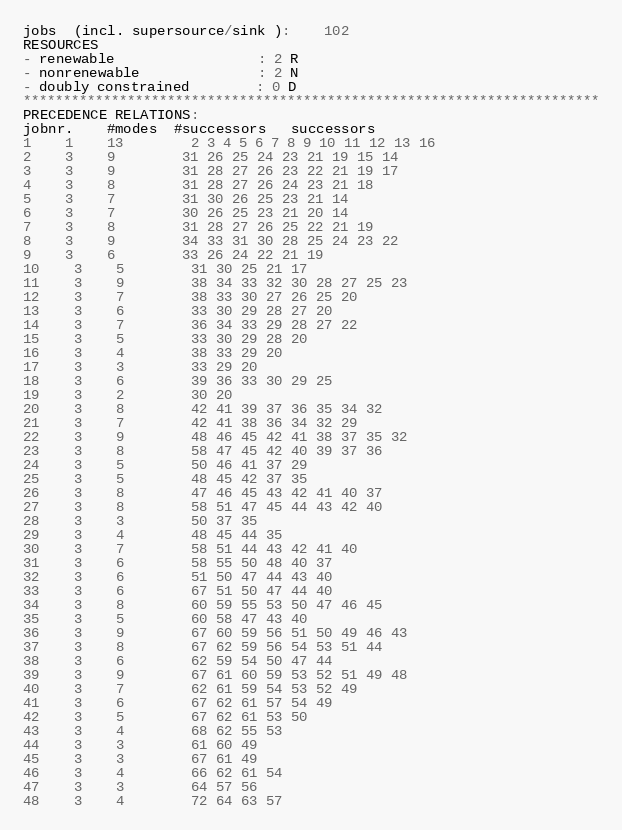<code> <loc_0><loc_0><loc_500><loc_500><_ObjectiveC_>jobs  (incl. supersource/sink ):	102
RESOURCES
- renewable                 : 2 R
- nonrenewable              : 2 N
- doubly constrained        : 0 D
************************************************************************
PRECEDENCE RELATIONS:
jobnr.    #modes  #successors   successors
1	1	13		2 3 4 5 6 7 8 9 10 11 12 13 16 
2	3	9		31 26 25 24 23 21 19 15 14 
3	3	9		31 28 27 26 23 22 21 19 17 
4	3	8		31 28 27 26 24 23 21 18 
5	3	7		31 30 26 25 23 21 14 
6	3	7		30 26 25 23 21 20 14 
7	3	8		31 28 27 26 25 22 21 19 
8	3	9		34 33 31 30 28 25 24 23 22 
9	3	6		33 26 24 22 21 19 
10	3	5		31 30 25 21 17 
11	3	9		38 34 33 32 30 28 27 25 23 
12	3	7		38 33 30 27 26 25 20 
13	3	6		33 30 29 28 27 20 
14	3	7		36 34 33 29 28 27 22 
15	3	5		33 30 29 28 20 
16	3	4		38 33 29 20 
17	3	3		33 29 20 
18	3	6		39 36 33 30 29 25 
19	3	2		30 20 
20	3	8		42 41 39 37 36 35 34 32 
21	3	7		42 41 38 36 34 32 29 
22	3	9		48 46 45 42 41 38 37 35 32 
23	3	8		58 47 45 42 40 39 37 36 
24	3	5		50 46 41 37 29 
25	3	5		48 45 42 37 35 
26	3	8		47 46 45 43 42 41 40 37 
27	3	8		58 51 47 45 44 43 42 40 
28	3	3		50 37 35 
29	3	4		48 45 44 35 
30	3	7		58 51 44 43 42 41 40 
31	3	6		58 55 50 48 40 37 
32	3	6		51 50 47 44 43 40 
33	3	6		67 51 50 47 44 40 
34	3	8		60 59 55 53 50 47 46 45 
35	3	5		60 58 47 43 40 
36	3	9		67 60 59 56 51 50 49 46 43 
37	3	8		67 62 59 56 54 53 51 44 
38	3	6		62 59 54 50 47 44 
39	3	9		67 61 60 59 53 52 51 49 48 
40	3	7		62 61 59 54 53 52 49 
41	3	6		67 62 61 57 54 49 
42	3	5		67 62 61 53 50 
43	3	4		68 62 55 53 
44	3	3		61 60 49 
45	3	3		67 61 49 
46	3	4		66 62 61 54 
47	3	3		64 57 56 
48	3	4		72 64 63 57 </code> 